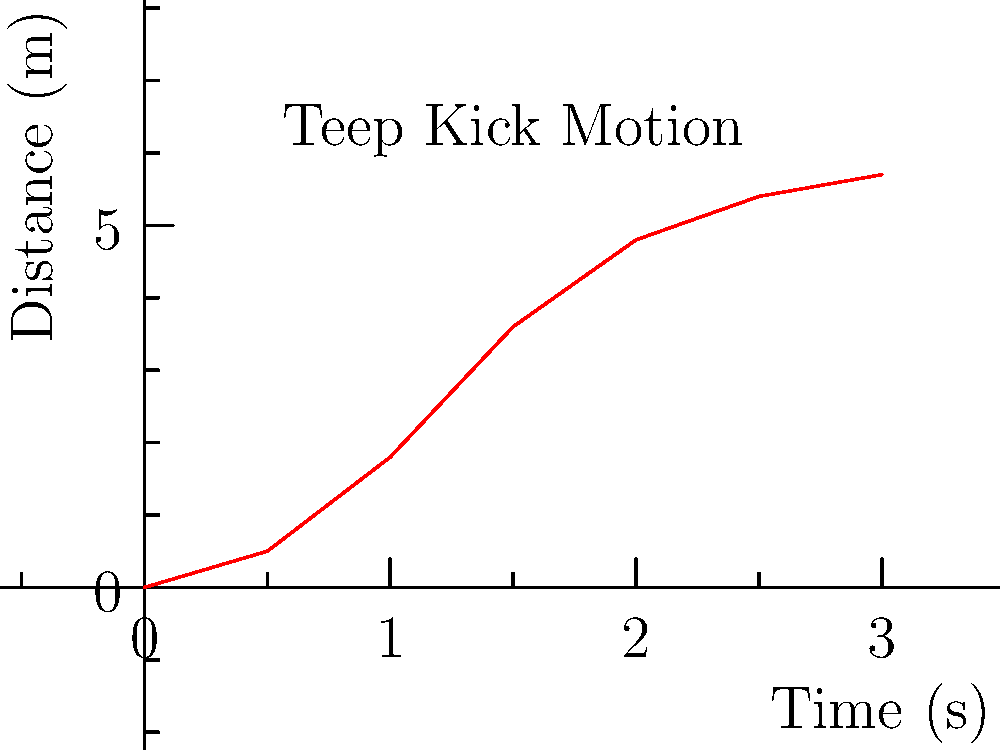Analyze the time-distance graph of a rapid-fire teep kick. At which time interval does the kick show the highest average velocity? To find the interval with the highest average velocity, we need to calculate the velocity for each interval and compare them. The average velocity is given by the formula:

$$ v_{avg} = \frac{\Delta d}{\Delta t} $$

Let's calculate for each interval:

1. 0 to 0.5s: $v_1 = \frac{0.5 - 0}{0.5 - 0} = 1$ m/s

2. 0.5 to 1s: $v_2 = \frac{1.8 - 0.5}{1 - 0.5} = 2.6$ m/s

3. 1 to 1.5s: $v_3 = \frac{3.6 - 1.8}{1.5 - 1} = 3.6$ m/s

4. 1.5 to 2s: $v_4 = \frac{4.8 - 3.6}{2 - 1.5} = 2.4$ m/s

5. 2 to 2.5s: $v_5 = \frac{5.4 - 4.8}{2.5 - 2} = 1.2$ m/s

6. 2.5 to 3s: $v_6 = \frac{5.7 - 5.4}{3 - 2.5} = 0.6$ m/s

The highest average velocity is 3.6 m/s, occurring in the interval from 1 to 1.5 seconds.
Answer: 1 to 1.5 seconds 